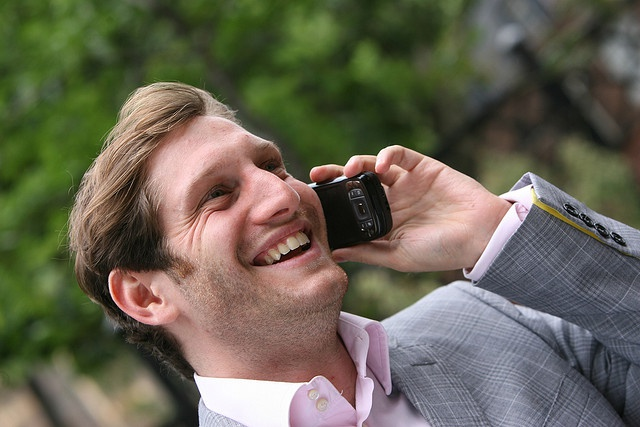Describe the objects in this image and their specific colors. I can see people in darkgreen, gray, black, and darkgray tones and cell phone in darkgreen, black, gray, maroon, and lightgray tones in this image. 